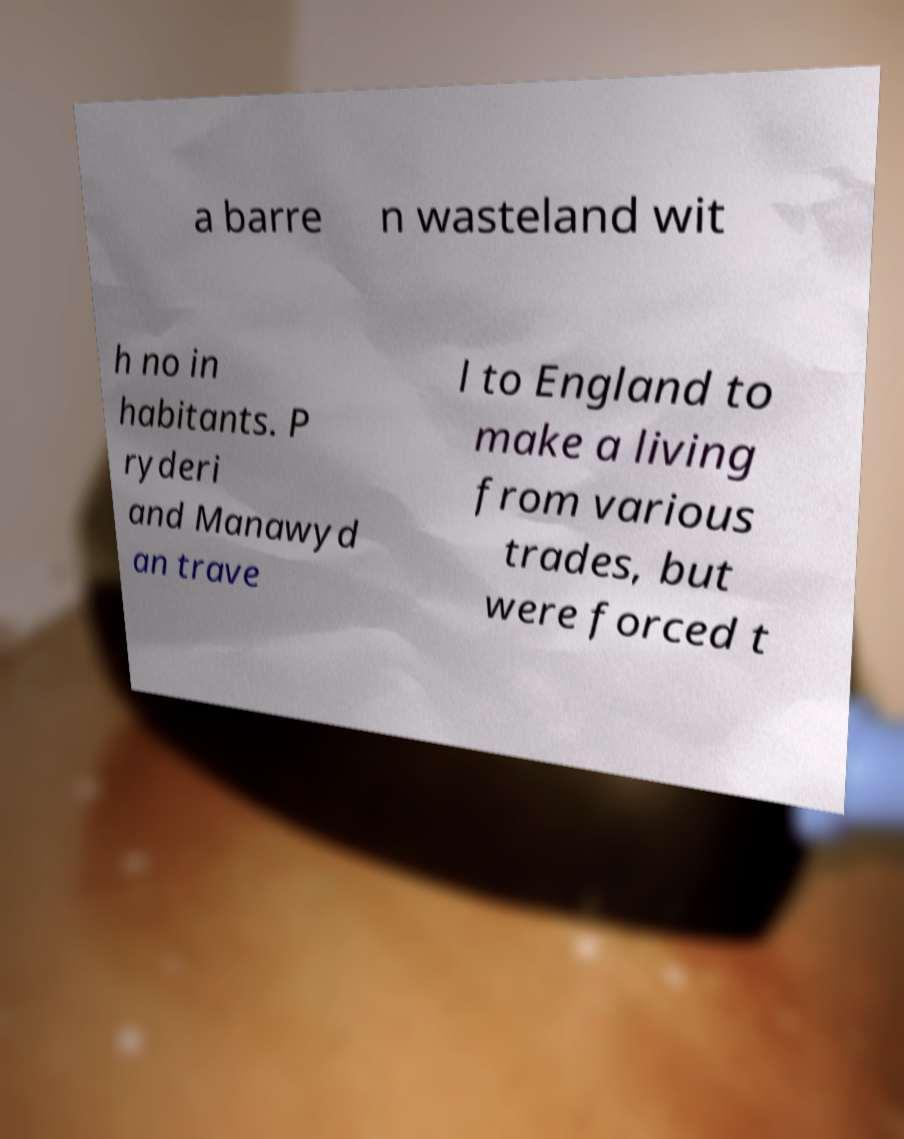Can you read and provide the text displayed in the image?This photo seems to have some interesting text. Can you extract and type it out for me? a barre n wasteland wit h no in habitants. P ryderi and Manawyd an trave l to England to make a living from various trades, but were forced t 